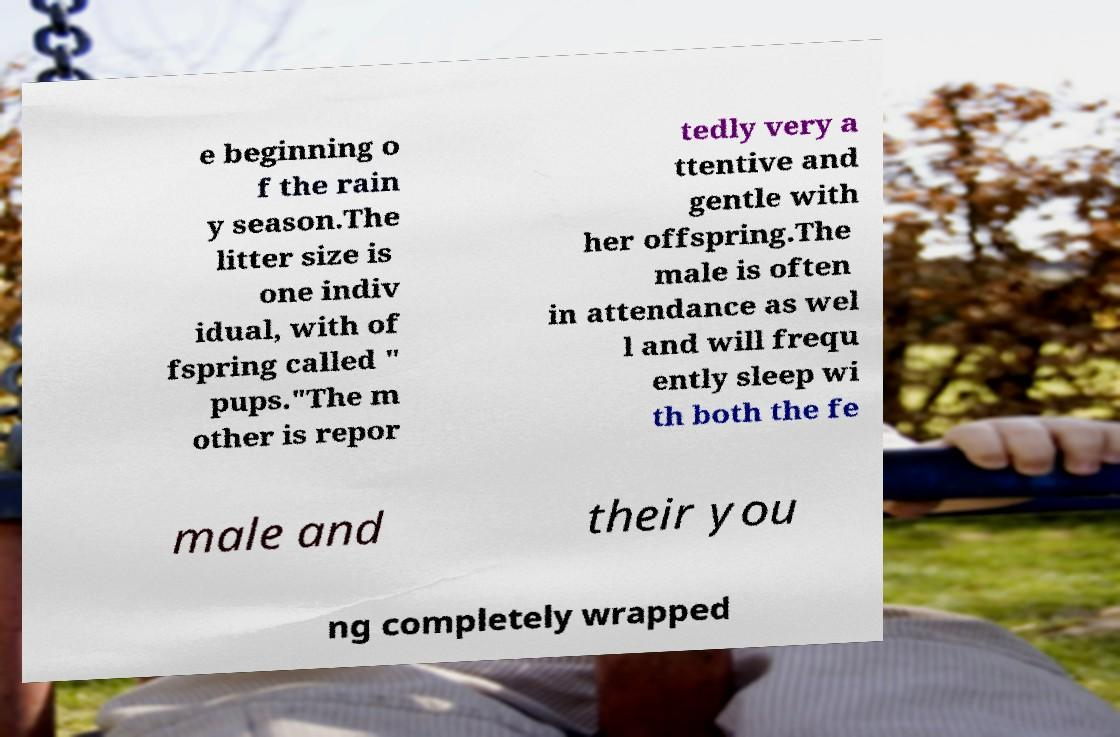What messages or text are displayed in this image? I need them in a readable, typed format. e beginning o f the rain y season.The litter size is one indiv idual, with of fspring called " pups."The m other is repor tedly very a ttentive and gentle with her offspring.The male is often in attendance as wel l and will frequ ently sleep wi th both the fe male and their you ng completely wrapped 